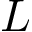<formula> <loc_0><loc_0><loc_500><loc_500>L</formula> 